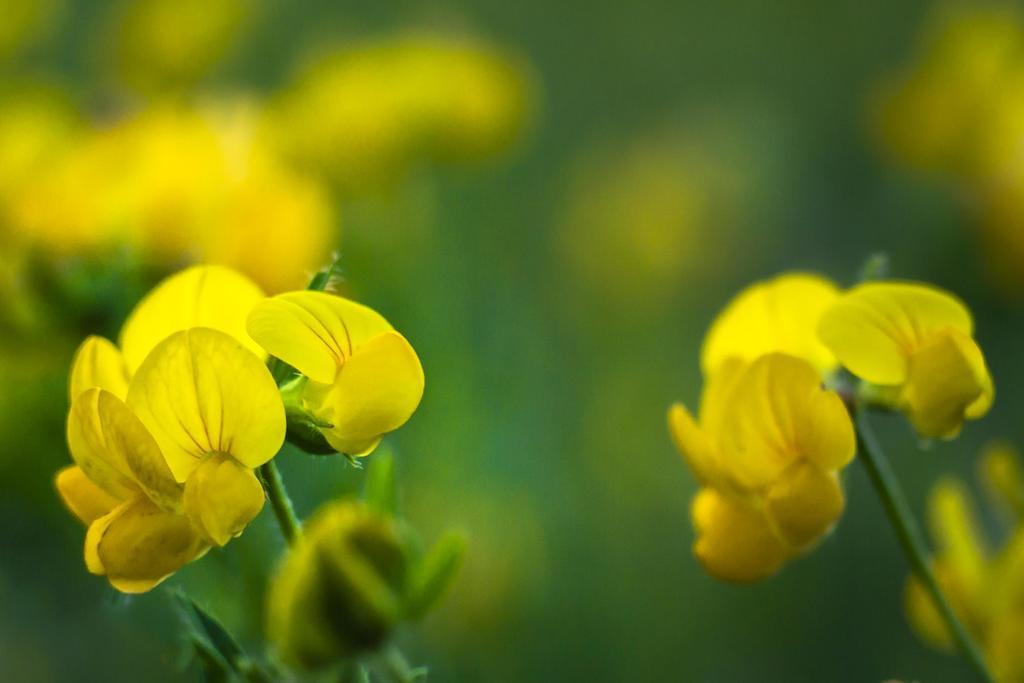What type of flowers can be seen in the image? There are yellow flowers in the image. Can you describe the quality of the image's background? The image is blurry in the background. What joke is being told by the flowers in the image? There is no joke being told by the flowers in the image, as flowers do not have the ability to tell jokes. 